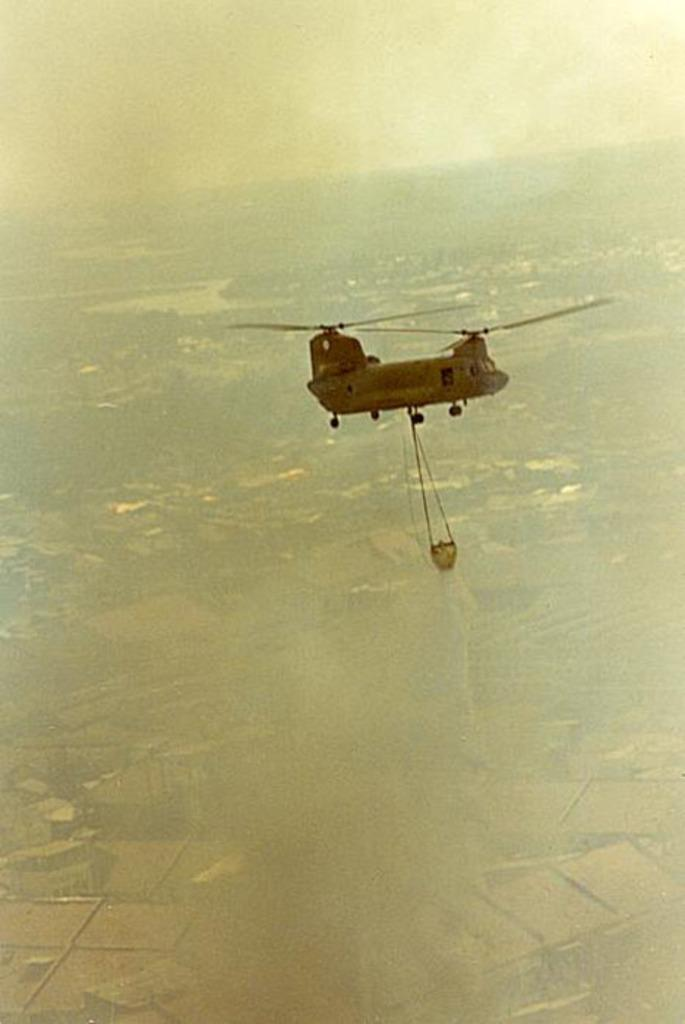What is the main subject of the image? The main subject of the image is an aircraft. What is the aircraft doing in the image? The aircraft is flying in the air. What is coming out of the aircraft? Water is coming out of the aircraft. What types of terrain can be seen in the image? There is land and water visible in the image. What is visible in the background of the image? The sky is visible in the background of the image. Can you see a kite flying in the sky in the image? There is no kite visible in the image; it only features an aircraft flying in the air. How many ducks are swimming in the water in the image? There are no ducks present in the image; it only features an aircraft flying in the air and water visible in the image. 